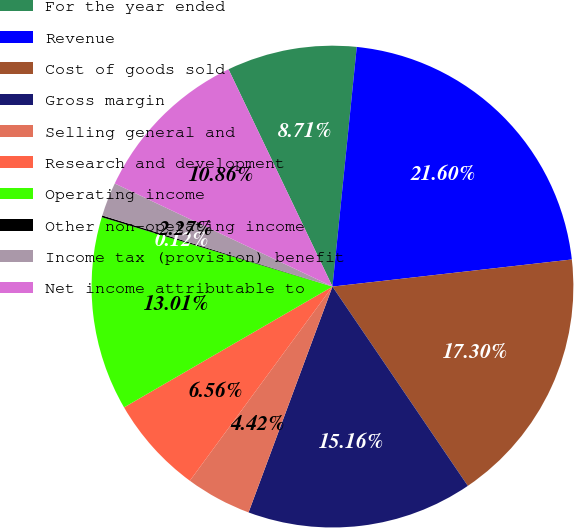Convert chart to OTSL. <chart><loc_0><loc_0><loc_500><loc_500><pie_chart><fcel>For the year ended<fcel>Revenue<fcel>Cost of goods sold<fcel>Gross margin<fcel>Selling general and<fcel>Research and development<fcel>Operating income<fcel>Other non-operating income<fcel>Income tax (provision) benefit<fcel>Net income attributable to<nl><fcel>8.71%<fcel>21.6%<fcel>17.3%<fcel>15.16%<fcel>4.42%<fcel>6.56%<fcel>13.01%<fcel>0.12%<fcel>2.27%<fcel>10.86%<nl></chart> 